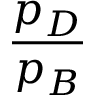Convert formula to latex. <formula><loc_0><loc_0><loc_500><loc_500>\frac { p _ { D } } { p _ { B } }</formula> 